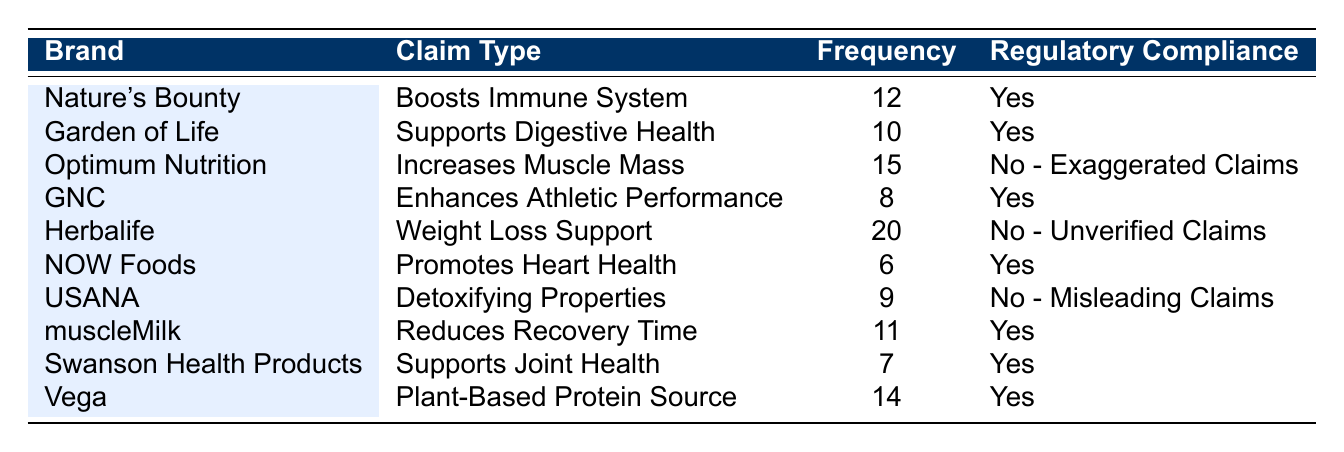What is the highest frequency of advertising claims from the table? The claim with the highest frequency of advertising is from Herbalife, with a frequency of 20.
Answer: 20 Which brand has claims that do not comply with regulatory guidelines? There are three brands with claims that do not comply: Optimum Nutrition, Herbalife, and USANA.
Answer: Optimum Nutrition, Herbalife, USANA What is the total frequency of claims made by brands that comply with regulatory guidelines? The complying brands are Nature's Bounty, Garden of Life, GNC, NOW Foods, muscleMilk, Swanson Health Products, and Vega. Their frequencies are 12, 10, 8, 6, 11, 7, and 14, giving a total of 12 + 10 + 8 + 6 + 11 + 7 + 14 = 68.
Answer: 68 How many brands make at least 10 claims? The brands with at least 10 claims are Nature's Bounty, Optimum Nutrition, Herbalife, muscleMilk, and Vega. That is 5 brands in total.
Answer: 5 What percentage of the claims are verified as compliant with regulatory guidelines? There are 7 brands with claims out of 10 that comply with regulatory guidelines, which is (7/10)*100 = 70%.
Answer: 70% Which claim type has the highest frequency, and which brand does it belong to? The highest frequency claim is "Weight Loss Support" from Herbalife, with a frequency of 20.
Answer: Weight Loss Support from Herbalife If a brand makes 15 claims, what is its compliance status? Optimum Nutrition makes 15 claims, but its compliance status is "No - Exaggerated Claims," meaning it does not comply with guidelines.
Answer: No - Exaggerated Claims Which claim type is associated with GNC, and what is its compliance status? GNC claims "Enhances Athletic Performance" with a frequency of 8, and it is compliant with regulatory guidelines.
Answer: Enhances Athletic Performance, Yes What is the difference in frequency between the highest and lowest non-compliant claims? The highest non-compliant claim is Herbalife with 20 claims, and the lowest is NOW Foods with 6 claims, making the difference 20 - 9 = 11.
Answer: 11 List the brands associated with claims that mention health benefits. The brands mentioning health benefits are Nature's Bounty, Garden of Life, GNC, NOW Foods, and Swanson Health Products.
Answer: Nature's Bounty, Garden of Life, GNC, NOW Foods, Swanson Health Products 